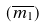Convert formula to latex. <formula><loc_0><loc_0><loc_500><loc_500>( \overline { m _ { 1 } } )</formula> 